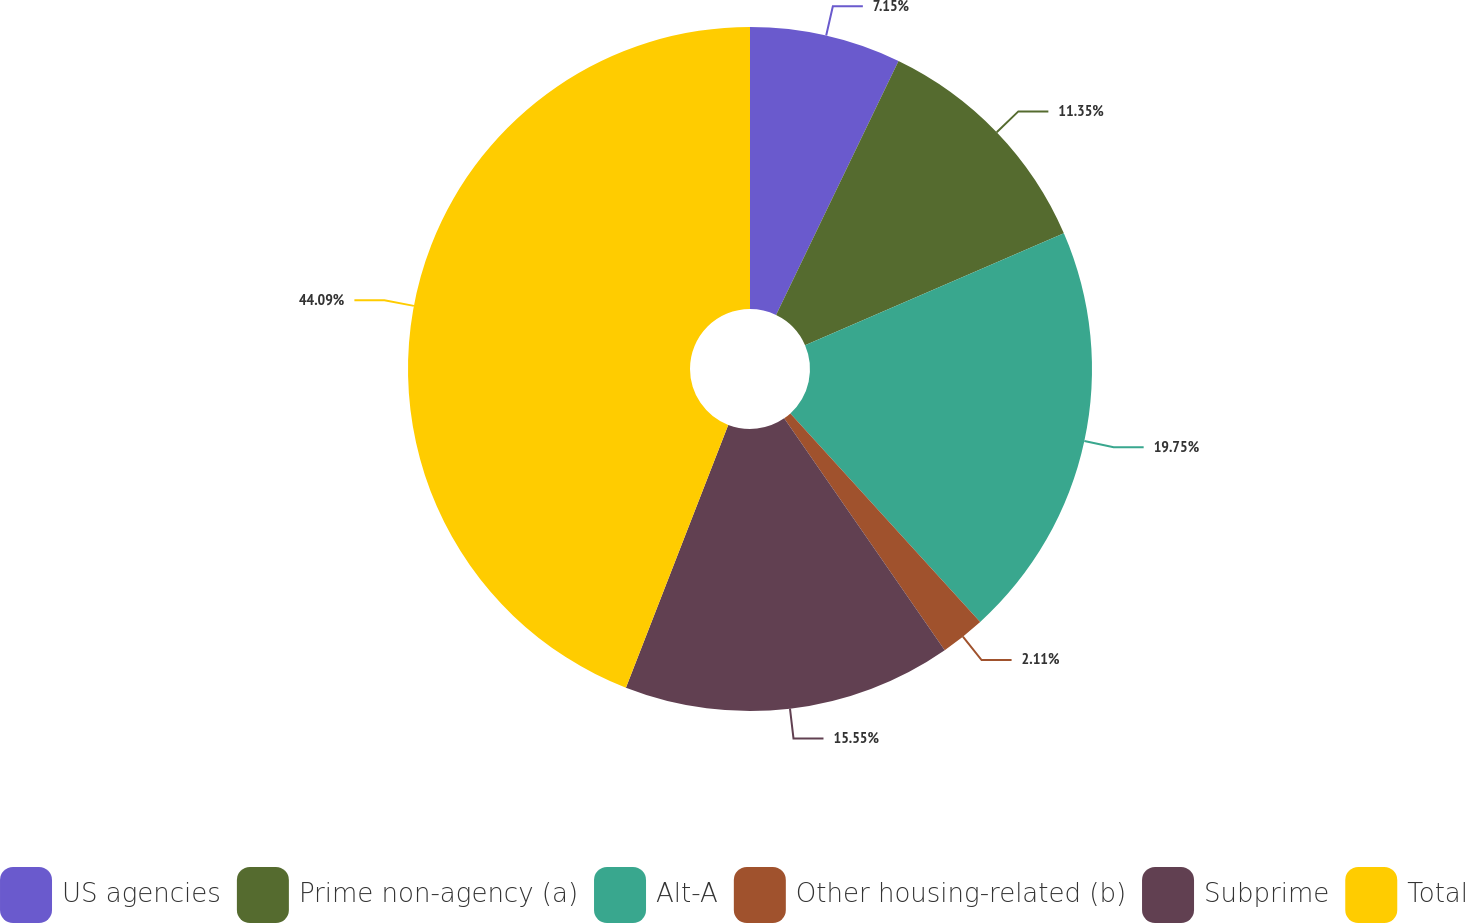<chart> <loc_0><loc_0><loc_500><loc_500><pie_chart><fcel>US agencies<fcel>Prime non-agency (a)<fcel>Alt-A<fcel>Other housing-related (b)<fcel>Subprime<fcel>Total<nl><fcel>7.15%<fcel>11.35%<fcel>19.75%<fcel>2.11%<fcel>15.55%<fcel>44.09%<nl></chart> 